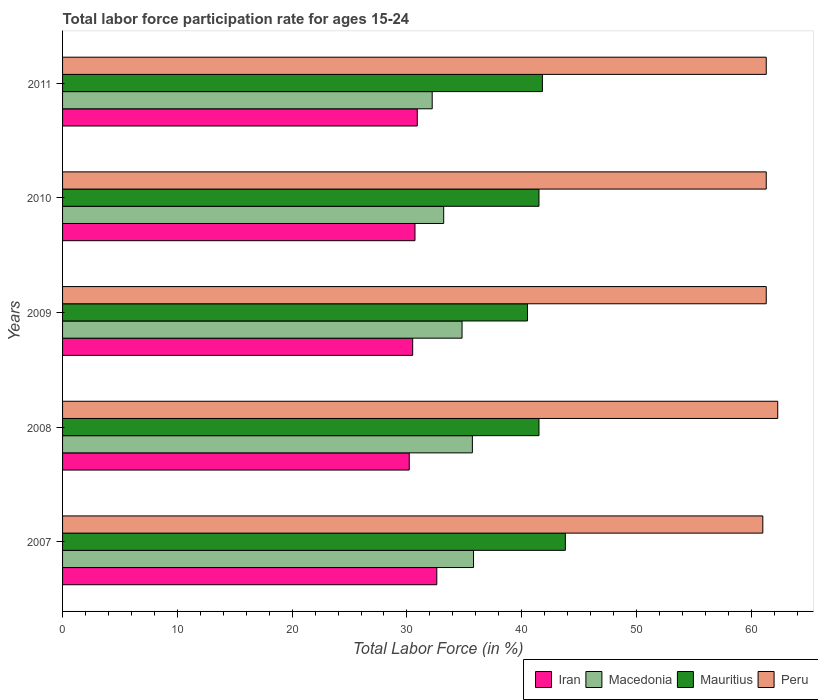How many different coloured bars are there?
Keep it short and to the point. 4. Are the number of bars on each tick of the Y-axis equal?
Offer a terse response. Yes. How many bars are there on the 1st tick from the top?
Provide a short and direct response. 4. How many bars are there on the 5th tick from the bottom?
Offer a terse response. 4. What is the label of the 4th group of bars from the top?
Offer a very short reply. 2008. What is the labor force participation rate in Mauritius in 2009?
Your answer should be very brief. 40.5. Across all years, what is the maximum labor force participation rate in Mauritius?
Your answer should be compact. 43.8. Across all years, what is the minimum labor force participation rate in Iran?
Your answer should be very brief. 30.2. In which year was the labor force participation rate in Macedonia minimum?
Ensure brevity in your answer.  2011. What is the total labor force participation rate in Mauritius in the graph?
Offer a very short reply. 209.1. What is the difference between the labor force participation rate in Mauritius in 2010 and that in 2011?
Give a very brief answer. -0.3. What is the difference between the labor force participation rate in Peru in 2010 and the labor force participation rate in Iran in 2009?
Give a very brief answer. 30.8. What is the average labor force participation rate in Iran per year?
Ensure brevity in your answer.  30.98. In the year 2011, what is the difference between the labor force participation rate in Iran and labor force participation rate in Mauritius?
Keep it short and to the point. -10.9. In how many years, is the labor force participation rate in Macedonia greater than 46 %?
Ensure brevity in your answer.  0. What is the ratio of the labor force participation rate in Mauritius in 2010 to that in 2011?
Keep it short and to the point. 0.99. Is the labor force participation rate in Mauritius in 2008 less than that in 2010?
Your response must be concise. No. Is the difference between the labor force participation rate in Iran in 2008 and 2011 greater than the difference between the labor force participation rate in Mauritius in 2008 and 2011?
Make the answer very short. No. What is the difference between the highest and the second highest labor force participation rate in Macedonia?
Your answer should be compact. 0.1. What is the difference between the highest and the lowest labor force participation rate in Peru?
Provide a succinct answer. 1.3. In how many years, is the labor force participation rate in Peru greater than the average labor force participation rate in Peru taken over all years?
Your answer should be very brief. 1. Is the sum of the labor force participation rate in Peru in 2008 and 2011 greater than the maximum labor force participation rate in Mauritius across all years?
Your answer should be compact. Yes. Is it the case that in every year, the sum of the labor force participation rate in Mauritius and labor force participation rate in Iran is greater than the sum of labor force participation rate in Macedonia and labor force participation rate in Peru?
Provide a short and direct response. No. What does the 1st bar from the top in 2009 represents?
Your answer should be very brief. Peru. How many bars are there?
Make the answer very short. 20. How many years are there in the graph?
Ensure brevity in your answer.  5. How many legend labels are there?
Keep it short and to the point. 4. What is the title of the graph?
Your answer should be very brief. Total labor force participation rate for ages 15-24. Does "Antigua and Barbuda" appear as one of the legend labels in the graph?
Keep it short and to the point. No. What is the label or title of the X-axis?
Offer a terse response. Total Labor Force (in %). What is the Total Labor Force (in %) of Iran in 2007?
Your answer should be compact. 32.6. What is the Total Labor Force (in %) of Macedonia in 2007?
Your answer should be very brief. 35.8. What is the Total Labor Force (in %) in Mauritius in 2007?
Your answer should be very brief. 43.8. What is the Total Labor Force (in %) in Iran in 2008?
Your answer should be very brief. 30.2. What is the Total Labor Force (in %) of Macedonia in 2008?
Make the answer very short. 35.7. What is the Total Labor Force (in %) of Mauritius in 2008?
Your answer should be very brief. 41.5. What is the Total Labor Force (in %) of Peru in 2008?
Your answer should be very brief. 62.3. What is the Total Labor Force (in %) in Iran in 2009?
Make the answer very short. 30.5. What is the Total Labor Force (in %) of Macedonia in 2009?
Give a very brief answer. 34.8. What is the Total Labor Force (in %) in Mauritius in 2009?
Provide a succinct answer. 40.5. What is the Total Labor Force (in %) of Peru in 2009?
Keep it short and to the point. 61.3. What is the Total Labor Force (in %) in Iran in 2010?
Provide a short and direct response. 30.7. What is the Total Labor Force (in %) of Macedonia in 2010?
Your response must be concise. 33.2. What is the Total Labor Force (in %) of Mauritius in 2010?
Provide a succinct answer. 41.5. What is the Total Labor Force (in %) in Peru in 2010?
Your answer should be compact. 61.3. What is the Total Labor Force (in %) of Iran in 2011?
Give a very brief answer. 30.9. What is the Total Labor Force (in %) in Macedonia in 2011?
Give a very brief answer. 32.2. What is the Total Labor Force (in %) of Mauritius in 2011?
Offer a terse response. 41.8. What is the Total Labor Force (in %) of Peru in 2011?
Provide a short and direct response. 61.3. Across all years, what is the maximum Total Labor Force (in %) of Iran?
Your response must be concise. 32.6. Across all years, what is the maximum Total Labor Force (in %) in Macedonia?
Give a very brief answer. 35.8. Across all years, what is the maximum Total Labor Force (in %) in Mauritius?
Ensure brevity in your answer.  43.8. Across all years, what is the maximum Total Labor Force (in %) of Peru?
Your answer should be compact. 62.3. Across all years, what is the minimum Total Labor Force (in %) in Iran?
Make the answer very short. 30.2. Across all years, what is the minimum Total Labor Force (in %) in Macedonia?
Keep it short and to the point. 32.2. Across all years, what is the minimum Total Labor Force (in %) in Mauritius?
Give a very brief answer. 40.5. Across all years, what is the minimum Total Labor Force (in %) in Peru?
Offer a very short reply. 61. What is the total Total Labor Force (in %) of Iran in the graph?
Keep it short and to the point. 154.9. What is the total Total Labor Force (in %) of Macedonia in the graph?
Give a very brief answer. 171.7. What is the total Total Labor Force (in %) in Mauritius in the graph?
Your response must be concise. 209.1. What is the total Total Labor Force (in %) in Peru in the graph?
Your answer should be very brief. 307.2. What is the difference between the Total Labor Force (in %) of Macedonia in 2007 and that in 2008?
Your answer should be compact. 0.1. What is the difference between the Total Labor Force (in %) of Mauritius in 2007 and that in 2008?
Your answer should be compact. 2.3. What is the difference between the Total Labor Force (in %) of Peru in 2007 and that in 2008?
Keep it short and to the point. -1.3. What is the difference between the Total Labor Force (in %) of Iran in 2007 and that in 2009?
Provide a short and direct response. 2.1. What is the difference between the Total Labor Force (in %) of Mauritius in 2007 and that in 2009?
Your answer should be very brief. 3.3. What is the difference between the Total Labor Force (in %) in Iran in 2007 and that in 2010?
Offer a very short reply. 1.9. What is the difference between the Total Labor Force (in %) in Iran in 2007 and that in 2011?
Your response must be concise. 1.7. What is the difference between the Total Labor Force (in %) in Mauritius in 2008 and that in 2009?
Provide a succinct answer. 1. What is the difference between the Total Labor Force (in %) of Peru in 2008 and that in 2009?
Offer a very short reply. 1. What is the difference between the Total Labor Force (in %) in Iran in 2008 and that in 2010?
Offer a terse response. -0.5. What is the difference between the Total Labor Force (in %) of Peru in 2008 and that in 2010?
Your answer should be compact. 1. What is the difference between the Total Labor Force (in %) in Iran in 2008 and that in 2011?
Your answer should be very brief. -0.7. What is the difference between the Total Labor Force (in %) in Mauritius in 2008 and that in 2011?
Your answer should be compact. -0.3. What is the difference between the Total Labor Force (in %) of Peru in 2008 and that in 2011?
Offer a terse response. 1. What is the difference between the Total Labor Force (in %) of Iran in 2009 and that in 2010?
Keep it short and to the point. -0.2. What is the difference between the Total Labor Force (in %) in Mauritius in 2009 and that in 2010?
Give a very brief answer. -1. What is the difference between the Total Labor Force (in %) of Peru in 2009 and that in 2010?
Give a very brief answer. 0. What is the difference between the Total Labor Force (in %) of Macedonia in 2009 and that in 2011?
Provide a succinct answer. 2.6. What is the difference between the Total Labor Force (in %) in Iran in 2010 and that in 2011?
Give a very brief answer. -0.2. What is the difference between the Total Labor Force (in %) of Macedonia in 2010 and that in 2011?
Offer a terse response. 1. What is the difference between the Total Labor Force (in %) in Mauritius in 2010 and that in 2011?
Provide a succinct answer. -0.3. What is the difference between the Total Labor Force (in %) in Peru in 2010 and that in 2011?
Give a very brief answer. 0. What is the difference between the Total Labor Force (in %) in Iran in 2007 and the Total Labor Force (in %) in Mauritius in 2008?
Offer a terse response. -8.9. What is the difference between the Total Labor Force (in %) in Iran in 2007 and the Total Labor Force (in %) in Peru in 2008?
Offer a terse response. -29.7. What is the difference between the Total Labor Force (in %) in Macedonia in 2007 and the Total Labor Force (in %) in Peru in 2008?
Provide a succinct answer. -26.5. What is the difference between the Total Labor Force (in %) of Mauritius in 2007 and the Total Labor Force (in %) of Peru in 2008?
Provide a short and direct response. -18.5. What is the difference between the Total Labor Force (in %) of Iran in 2007 and the Total Labor Force (in %) of Peru in 2009?
Provide a succinct answer. -28.7. What is the difference between the Total Labor Force (in %) of Macedonia in 2007 and the Total Labor Force (in %) of Peru in 2009?
Give a very brief answer. -25.5. What is the difference between the Total Labor Force (in %) in Mauritius in 2007 and the Total Labor Force (in %) in Peru in 2009?
Offer a terse response. -17.5. What is the difference between the Total Labor Force (in %) in Iran in 2007 and the Total Labor Force (in %) in Peru in 2010?
Provide a short and direct response. -28.7. What is the difference between the Total Labor Force (in %) of Macedonia in 2007 and the Total Labor Force (in %) of Peru in 2010?
Ensure brevity in your answer.  -25.5. What is the difference between the Total Labor Force (in %) of Mauritius in 2007 and the Total Labor Force (in %) of Peru in 2010?
Provide a short and direct response. -17.5. What is the difference between the Total Labor Force (in %) in Iran in 2007 and the Total Labor Force (in %) in Macedonia in 2011?
Provide a short and direct response. 0.4. What is the difference between the Total Labor Force (in %) of Iran in 2007 and the Total Labor Force (in %) of Peru in 2011?
Offer a very short reply. -28.7. What is the difference between the Total Labor Force (in %) of Macedonia in 2007 and the Total Labor Force (in %) of Peru in 2011?
Ensure brevity in your answer.  -25.5. What is the difference between the Total Labor Force (in %) of Mauritius in 2007 and the Total Labor Force (in %) of Peru in 2011?
Give a very brief answer. -17.5. What is the difference between the Total Labor Force (in %) in Iran in 2008 and the Total Labor Force (in %) in Macedonia in 2009?
Keep it short and to the point. -4.6. What is the difference between the Total Labor Force (in %) in Iran in 2008 and the Total Labor Force (in %) in Mauritius in 2009?
Keep it short and to the point. -10.3. What is the difference between the Total Labor Force (in %) in Iran in 2008 and the Total Labor Force (in %) in Peru in 2009?
Provide a short and direct response. -31.1. What is the difference between the Total Labor Force (in %) in Macedonia in 2008 and the Total Labor Force (in %) in Peru in 2009?
Make the answer very short. -25.6. What is the difference between the Total Labor Force (in %) of Mauritius in 2008 and the Total Labor Force (in %) of Peru in 2009?
Keep it short and to the point. -19.8. What is the difference between the Total Labor Force (in %) of Iran in 2008 and the Total Labor Force (in %) of Peru in 2010?
Provide a succinct answer. -31.1. What is the difference between the Total Labor Force (in %) in Macedonia in 2008 and the Total Labor Force (in %) in Mauritius in 2010?
Provide a short and direct response. -5.8. What is the difference between the Total Labor Force (in %) in Macedonia in 2008 and the Total Labor Force (in %) in Peru in 2010?
Your answer should be compact. -25.6. What is the difference between the Total Labor Force (in %) in Mauritius in 2008 and the Total Labor Force (in %) in Peru in 2010?
Offer a very short reply. -19.8. What is the difference between the Total Labor Force (in %) of Iran in 2008 and the Total Labor Force (in %) of Peru in 2011?
Your response must be concise. -31.1. What is the difference between the Total Labor Force (in %) of Macedonia in 2008 and the Total Labor Force (in %) of Mauritius in 2011?
Provide a succinct answer. -6.1. What is the difference between the Total Labor Force (in %) in Macedonia in 2008 and the Total Labor Force (in %) in Peru in 2011?
Offer a very short reply. -25.6. What is the difference between the Total Labor Force (in %) of Mauritius in 2008 and the Total Labor Force (in %) of Peru in 2011?
Give a very brief answer. -19.8. What is the difference between the Total Labor Force (in %) of Iran in 2009 and the Total Labor Force (in %) of Macedonia in 2010?
Provide a succinct answer. -2.7. What is the difference between the Total Labor Force (in %) of Iran in 2009 and the Total Labor Force (in %) of Peru in 2010?
Offer a terse response. -30.8. What is the difference between the Total Labor Force (in %) of Macedonia in 2009 and the Total Labor Force (in %) of Mauritius in 2010?
Your response must be concise. -6.7. What is the difference between the Total Labor Force (in %) of Macedonia in 2009 and the Total Labor Force (in %) of Peru in 2010?
Ensure brevity in your answer.  -26.5. What is the difference between the Total Labor Force (in %) in Mauritius in 2009 and the Total Labor Force (in %) in Peru in 2010?
Give a very brief answer. -20.8. What is the difference between the Total Labor Force (in %) in Iran in 2009 and the Total Labor Force (in %) in Peru in 2011?
Give a very brief answer. -30.8. What is the difference between the Total Labor Force (in %) in Macedonia in 2009 and the Total Labor Force (in %) in Mauritius in 2011?
Your answer should be very brief. -7. What is the difference between the Total Labor Force (in %) in Macedonia in 2009 and the Total Labor Force (in %) in Peru in 2011?
Provide a short and direct response. -26.5. What is the difference between the Total Labor Force (in %) of Mauritius in 2009 and the Total Labor Force (in %) of Peru in 2011?
Provide a succinct answer. -20.8. What is the difference between the Total Labor Force (in %) of Iran in 2010 and the Total Labor Force (in %) of Mauritius in 2011?
Make the answer very short. -11.1. What is the difference between the Total Labor Force (in %) in Iran in 2010 and the Total Labor Force (in %) in Peru in 2011?
Keep it short and to the point. -30.6. What is the difference between the Total Labor Force (in %) in Macedonia in 2010 and the Total Labor Force (in %) in Mauritius in 2011?
Make the answer very short. -8.6. What is the difference between the Total Labor Force (in %) of Macedonia in 2010 and the Total Labor Force (in %) of Peru in 2011?
Keep it short and to the point. -28.1. What is the difference between the Total Labor Force (in %) of Mauritius in 2010 and the Total Labor Force (in %) of Peru in 2011?
Provide a short and direct response. -19.8. What is the average Total Labor Force (in %) in Iran per year?
Your answer should be compact. 30.98. What is the average Total Labor Force (in %) of Macedonia per year?
Your response must be concise. 34.34. What is the average Total Labor Force (in %) in Mauritius per year?
Keep it short and to the point. 41.82. What is the average Total Labor Force (in %) of Peru per year?
Your response must be concise. 61.44. In the year 2007, what is the difference between the Total Labor Force (in %) of Iran and Total Labor Force (in %) of Peru?
Offer a very short reply. -28.4. In the year 2007, what is the difference between the Total Labor Force (in %) in Macedonia and Total Labor Force (in %) in Mauritius?
Your answer should be very brief. -8. In the year 2007, what is the difference between the Total Labor Force (in %) in Macedonia and Total Labor Force (in %) in Peru?
Provide a succinct answer. -25.2. In the year 2007, what is the difference between the Total Labor Force (in %) in Mauritius and Total Labor Force (in %) in Peru?
Your answer should be very brief. -17.2. In the year 2008, what is the difference between the Total Labor Force (in %) of Iran and Total Labor Force (in %) of Peru?
Give a very brief answer. -32.1. In the year 2008, what is the difference between the Total Labor Force (in %) in Macedonia and Total Labor Force (in %) in Mauritius?
Your answer should be compact. -5.8. In the year 2008, what is the difference between the Total Labor Force (in %) in Macedonia and Total Labor Force (in %) in Peru?
Make the answer very short. -26.6. In the year 2008, what is the difference between the Total Labor Force (in %) of Mauritius and Total Labor Force (in %) of Peru?
Provide a short and direct response. -20.8. In the year 2009, what is the difference between the Total Labor Force (in %) in Iran and Total Labor Force (in %) in Peru?
Your answer should be compact. -30.8. In the year 2009, what is the difference between the Total Labor Force (in %) in Macedonia and Total Labor Force (in %) in Peru?
Provide a succinct answer. -26.5. In the year 2009, what is the difference between the Total Labor Force (in %) of Mauritius and Total Labor Force (in %) of Peru?
Give a very brief answer. -20.8. In the year 2010, what is the difference between the Total Labor Force (in %) in Iran and Total Labor Force (in %) in Macedonia?
Provide a short and direct response. -2.5. In the year 2010, what is the difference between the Total Labor Force (in %) of Iran and Total Labor Force (in %) of Mauritius?
Give a very brief answer. -10.8. In the year 2010, what is the difference between the Total Labor Force (in %) in Iran and Total Labor Force (in %) in Peru?
Offer a very short reply. -30.6. In the year 2010, what is the difference between the Total Labor Force (in %) of Macedonia and Total Labor Force (in %) of Mauritius?
Your answer should be very brief. -8.3. In the year 2010, what is the difference between the Total Labor Force (in %) in Macedonia and Total Labor Force (in %) in Peru?
Give a very brief answer. -28.1. In the year 2010, what is the difference between the Total Labor Force (in %) in Mauritius and Total Labor Force (in %) in Peru?
Your response must be concise. -19.8. In the year 2011, what is the difference between the Total Labor Force (in %) of Iran and Total Labor Force (in %) of Macedonia?
Keep it short and to the point. -1.3. In the year 2011, what is the difference between the Total Labor Force (in %) of Iran and Total Labor Force (in %) of Peru?
Offer a terse response. -30.4. In the year 2011, what is the difference between the Total Labor Force (in %) of Macedonia and Total Labor Force (in %) of Mauritius?
Keep it short and to the point. -9.6. In the year 2011, what is the difference between the Total Labor Force (in %) in Macedonia and Total Labor Force (in %) in Peru?
Your answer should be very brief. -29.1. In the year 2011, what is the difference between the Total Labor Force (in %) in Mauritius and Total Labor Force (in %) in Peru?
Ensure brevity in your answer.  -19.5. What is the ratio of the Total Labor Force (in %) of Iran in 2007 to that in 2008?
Your response must be concise. 1.08. What is the ratio of the Total Labor Force (in %) in Mauritius in 2007 to that in 2008?
Make the answer very short. 1.06. What is the ratio of the Total Labor Force (in %) in Peru in 2007 to that in 2008?
Provide a short and direct response. 0.98. What is the ratio of the Total Labor Force (in %) of Iran in 2007 to that in 2009?
Offer a terse response. 1.07. What is the ratio of the Total Labor Force (in %) in Macedonia in 2007 to that in 2009?
Ensure brevity in your answer.  1.03. What is the ratio of the Total Labor Force (in %) of Mauritius in 2007 to that in 2009?
Keep it short and to the point. 1.08. What is the ratio of the Total Labor Force (in %) in Iran in 2007 to that in 2010?
Offer a very short reply. 1.06. What is the ratio of the Total Labor Force (in %) of Macedonia in 2007 to that in 2010?
Keep it short and to the point. 1.08. What is the ratio of the Total Labor Force (in %) of Mauritius in 2007 to that in 2010?
Provide a succinct answer. 1.06. What is the ratio of the Total Labor Force (in %) of Iran in 2007 to that in 2011?
Offer a terse response. 1.05. What is the ratio of the Total Labor Force (in %) in Macedonia in 2007 to that in 2011?
Give a very brief answer. 1.11. What is the ratio of the Total Labor Force (in %) in Mauritius in 2007 to that in 2011?
Ensure brevity in your answer.  1.05. What is the ratio of the Total Labor Force (in %) in Peru in 2007 to that in 2011?
Give a very brief answer. 1. What is the ratio of the Total Labor Force (in %) in Iran in 2008 to that in 2009?
Keep it short and to the point. 0.99. What is the ratio of the Total Labor Force (in %) of Macedonia in 2008 to that in 2009?
Provide a short and direct response. 1.03. What is the ratio of the Total Labor Force (in %) of Mauritius in 2008 to that in 2009?
Your answer should be compact. 1.02. What is the ratio of the Total Labor Force (in %) in Peru in 2008 to that in 2009?
Offer a terse response. 1.02. What is the ratio of the Total Labor Force (in %) in Iran in 2008 to that in 2010?
Provide a short and direct response. 0.98. What is the ratio of the Total Labor Force (in %) in Macedonia in 2008 to that in 2010?
Keep it short and to the point. 1.08. What is the ratio of the Total Labor Force (in %) in Peru in 2008 to that in 2010?
Keep it short and to the point. 1.02. What is the ratio of the Total Labor Force (in %) of Iran in 2008 to that in 2011?
Your answer should be compact. 0.98. What is the ratio of the Total Labor Force (in %) of Macedonia in 2008 to that in 2011?
Make the answer very short. 1.11. What is the ratio of the Total Labor Force (in %) of Peru in 2008 to that in 2011?
Provide a succinct answer. 1.02. What is the ratio of the Total Labor Force (in %) of Macedonia in 2009 to that in 2010?
Provide a succinct answer. 1.05. What is the ratio of the Total Labor Force (in %) in Mauritius in 2009 to that in 2010?
Make the answer very short. 0.98. What is the ratio of the Total Labor Force (in %) in Iran in 2009 to that in 2011?
Provide a short and direct response. 0.99. What is the ratio of the Total Labor Force (in %) in Macedonia in 2009 to that in 2011?
Offer a terse response. 1.08. What is the ratio of the Total Labor Force (in %) of Mauritius in 2009 to that in 2011?
Keep it short and to the point. 0.97. What is the ratio of the Total Labor Force (in %) in Macedonia in 2010 to that in 2011?
Make the answer very short. 1.03. What is the difference between the highest and the second highest Total Labor Force (in %) in Macedonia?
Your answer should be very brief. 0.1. What is the difference between the highest and the second highest Total Labor Force (in %) in Mauritius?
Your answer should be very brief. 2. What is the difference between the highest and the second highest Total Labor Force (in %) of Peru?
Make the answer very short. 1. What is the difference between the highest and the lowest Total Labor Force (in %) in Iran?
Offer a terse response. 2.4. What is the difference between the highest and the lowest Total Labor Force (in %) of Macedonia?
Make the answer very short. 3.6. What is the difference between the highest and the lowest Total Labor Force (in %) in Mauritius?
Your answer should be compact. 3.3. 